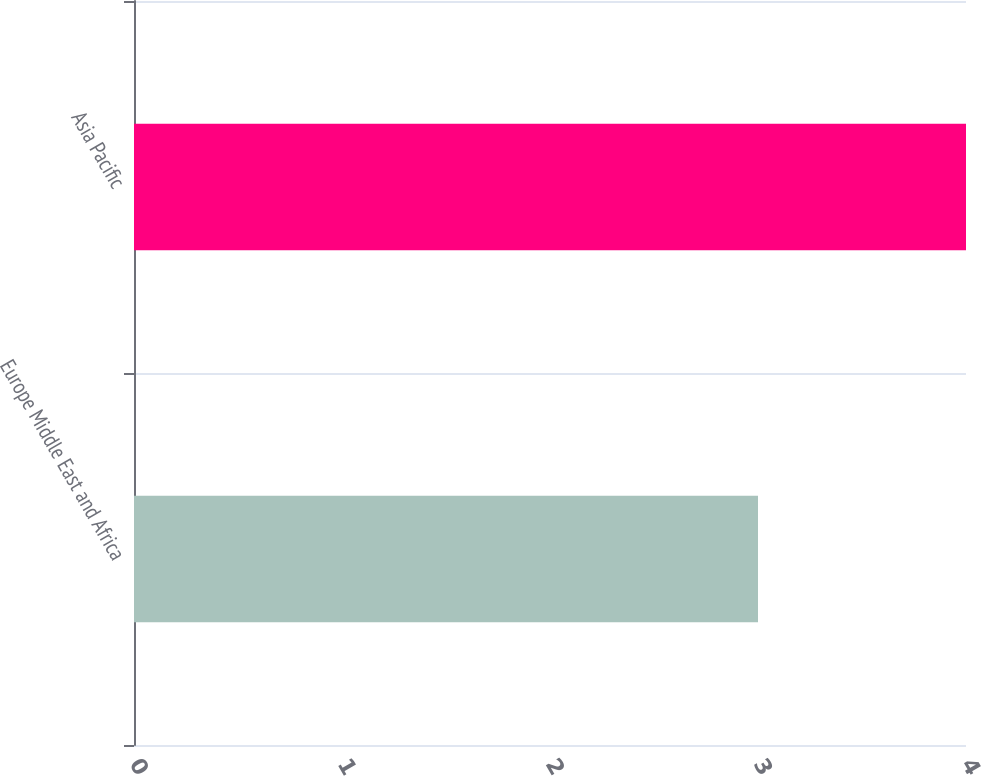Convert chart to OTSL. <chart><loc_0><loc_0><loc_500><loc_500><bar_chart><fcel>Europe Middle East and Africa<fcel>Asia Pacific<nl><fcel>3<fcel>4<nl></chart> 